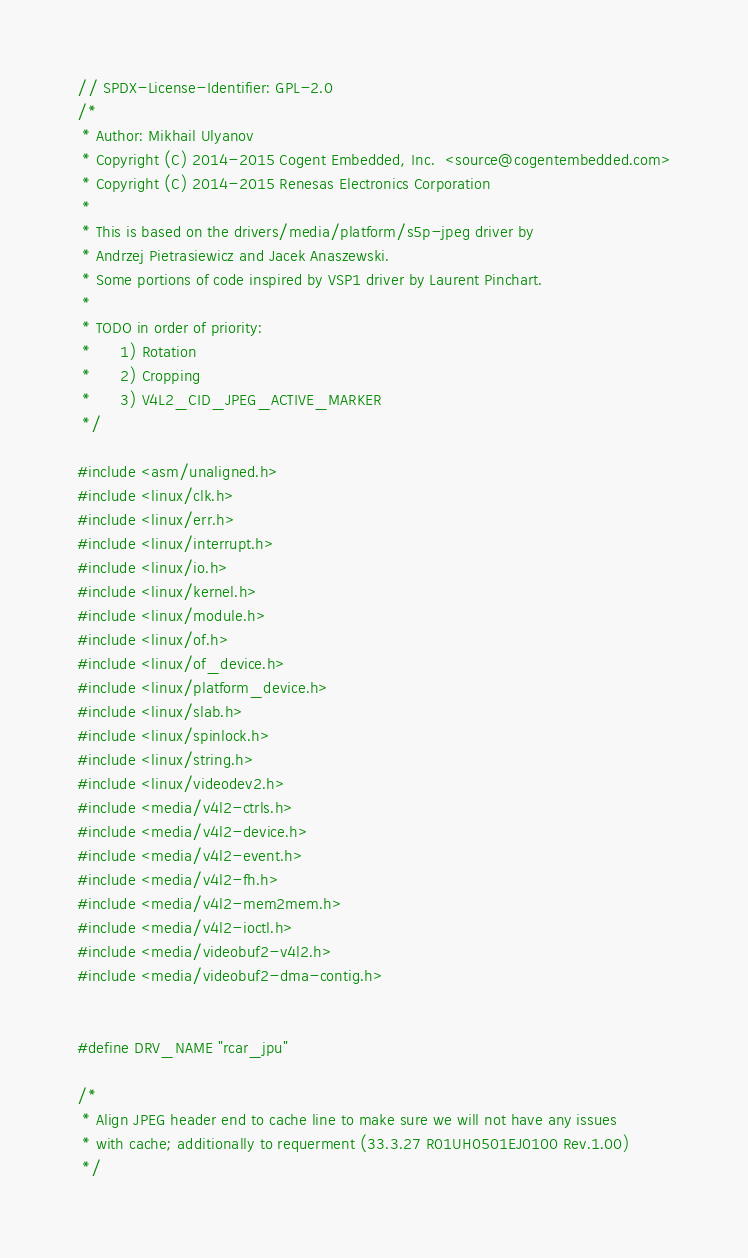<code> <loc_0><loc_0><loc_500><loc_500><_C_>// SPDX-License-Identifier: GPL-2.0
/*
 * Author: Mikhail Ulyanov
 * Copyright (C) 2014-2015 Cogent Embedded, Inc.  <source@cogentembedded.com>
 * Copyright (C) 2014-2015 Renesas Electronics Corporation
 *
 * This is based on the drivers/media/platform/s5p-jpeg driver by
 * Andrzej Pietrasiewicz and Jacek Anaszewski.
 * Some portions of code inspired by VSP1 driver by Laurent Pinchart.
 *
 * TODO in order of priority:
 *      1) Rotation
 *      2) Cropping
 *      3) V4L2_CID_JPEG_ACTIVE_MARKER
 */

#include <asm/unaligned.h>
#include <linux/clk.h>
#include <linux/err.h>
#include <linux/interrupt.h>
#include <linux/io.h>
#include <linux/kernel.h>
#include <linux/module.h>
#include <linux/of.h>
#include <linux/of_device.h>
#include <linux/platform_device.h>
#include <linux/slab.h>
#include <linux/spinlock.h>
#include <linux/string.h>
#include <linux/videodev2.h>
#include <media/v4l2-ctrls.h>
#include <media/v4l2-device.h>
#include <media/v4l2-event.h>
#include <media/v4l2-fh.h>
#include <media/v4l2-mem2mem.h>
#include <media/v4l2-ioctl.h>
#include <media/videobuf2-v4l2.h>
#include <media/videobuf2-dma-contig.h>


#define DRV_NAME "rcar_jpu"

/*
 * Align JPEG header end to cache line to make sure we will not have any issues
 * with cache; additionally to requerment (33.3.27 R01UH0501EJ0100 Rev.1.00)
 */</code> 